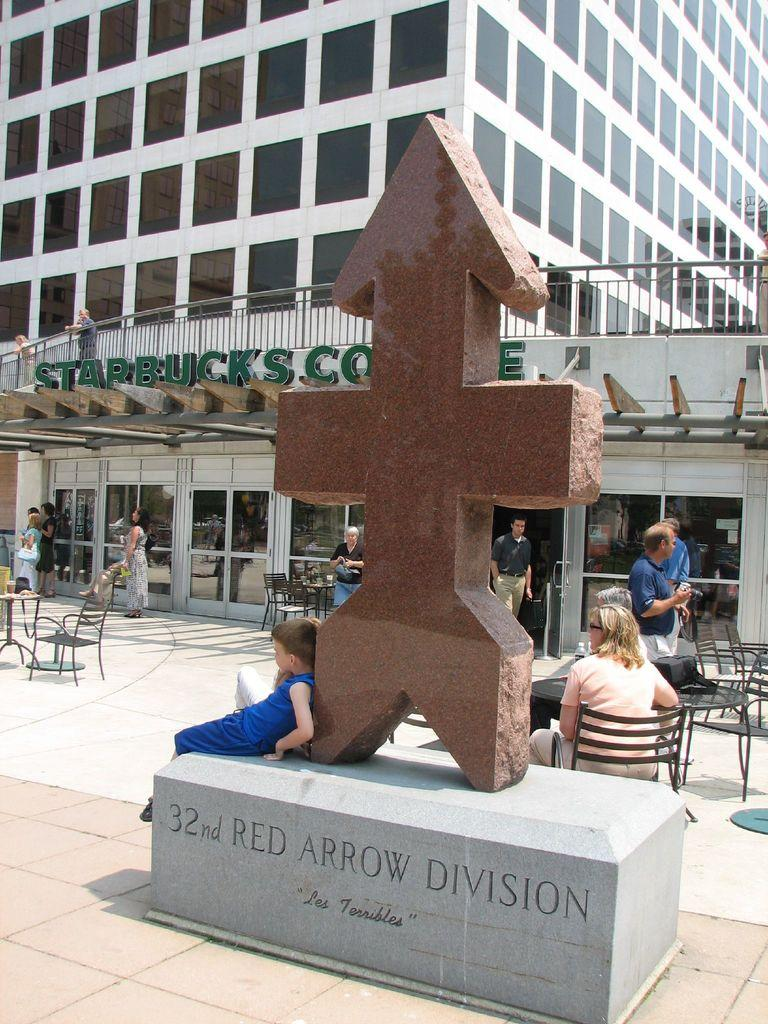What type of structure is depicted in the image? The image contains a huge building that is a store. Can you describe any specific features of the building? There is a stone carving in the image. What is happening around the store in the image? There are people standing near the store, and there are chairs where people are sitting. Can you see any fangs on the people sitting in the chairs in the image? There are no fangs visible on the people sitting in the chairs in the image. What type of rifle is being used by the stone carving in the image? There is no rifle present in the image; it features a stone carving on the building. 